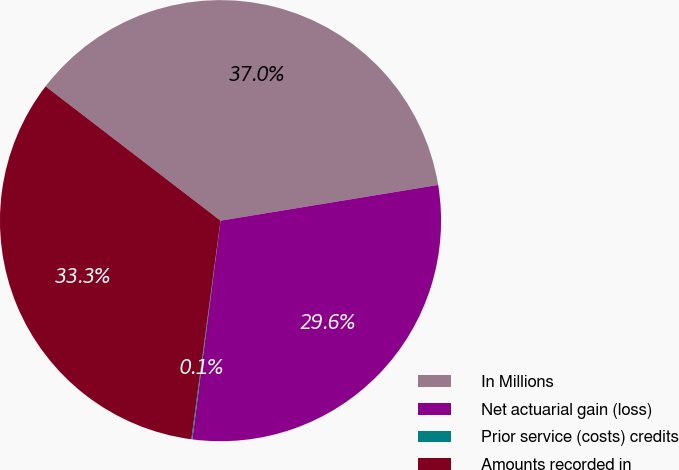Convert chart. <chart><loc_0><loc_0><loc_500><loc_500><pie_chart><fcel>In Millions<fcel>Net actuarial gain (loss)<fcel>Prior service (costs) credits<fcel>Amounts recorded in<nl><fcel>36.99%<fcel>29.63%<fcel>0.07%<fcel>33.31%<nl></chart> 